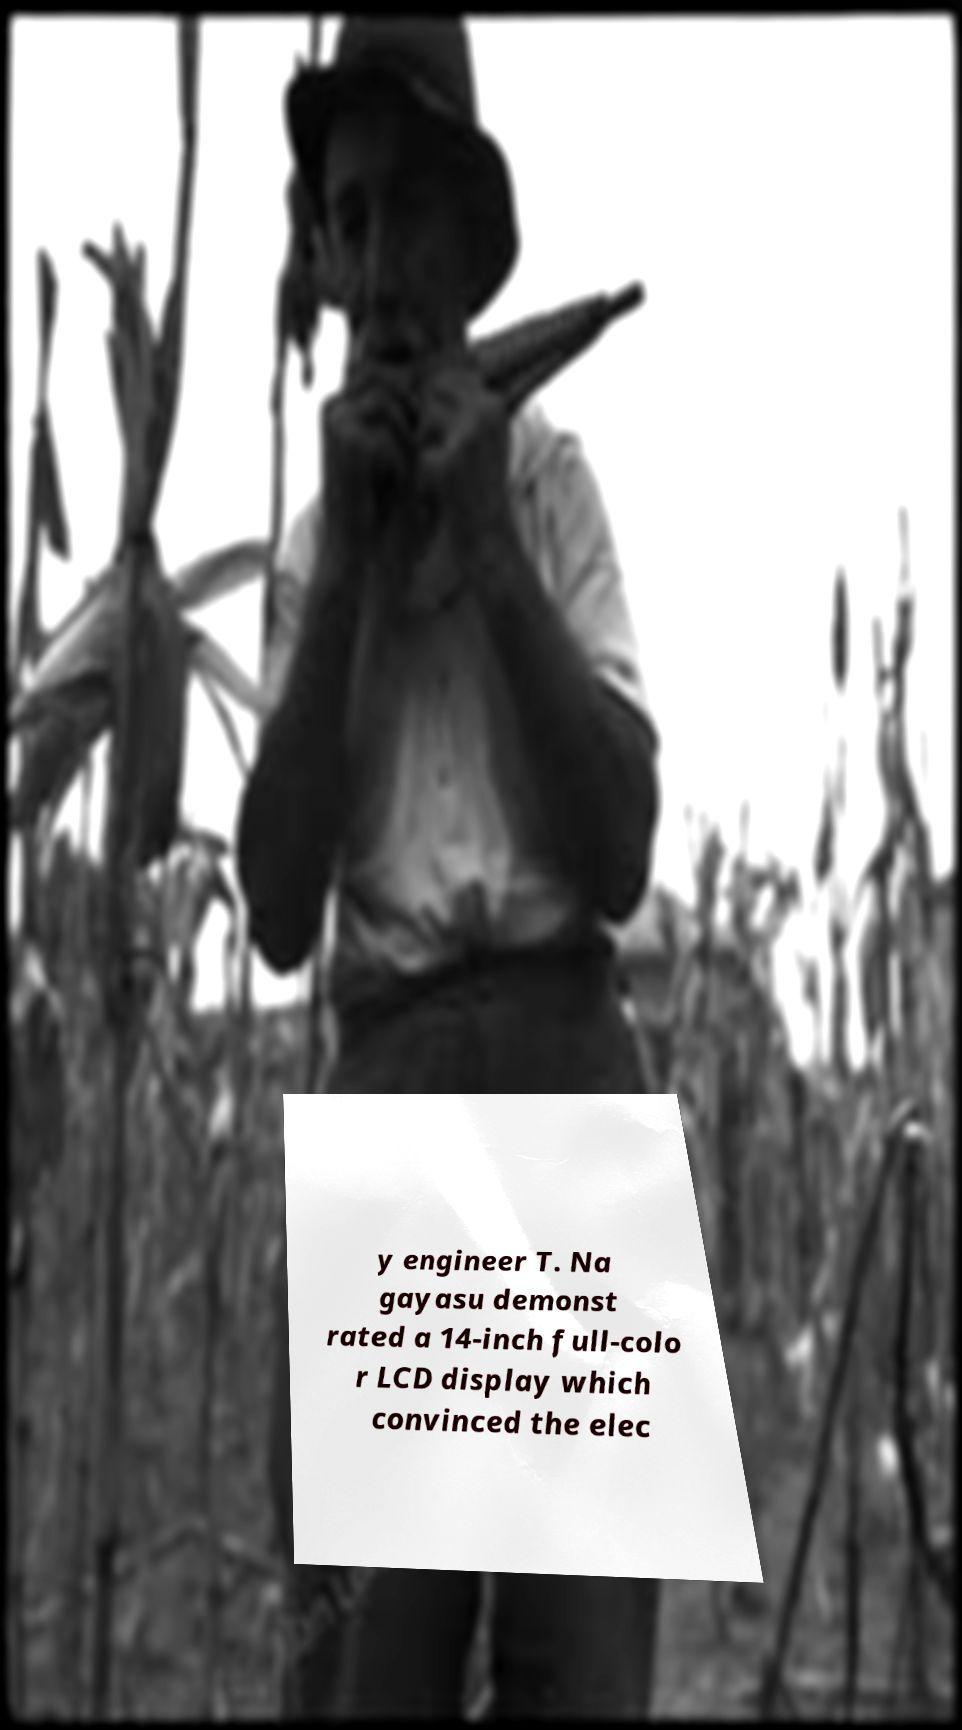What messages or text are displayed in this image? I need them in a readable, typed format. y engineer T. Na gayasu demonst rated a 14-inch full-colo r LCD display which convinced the elec 